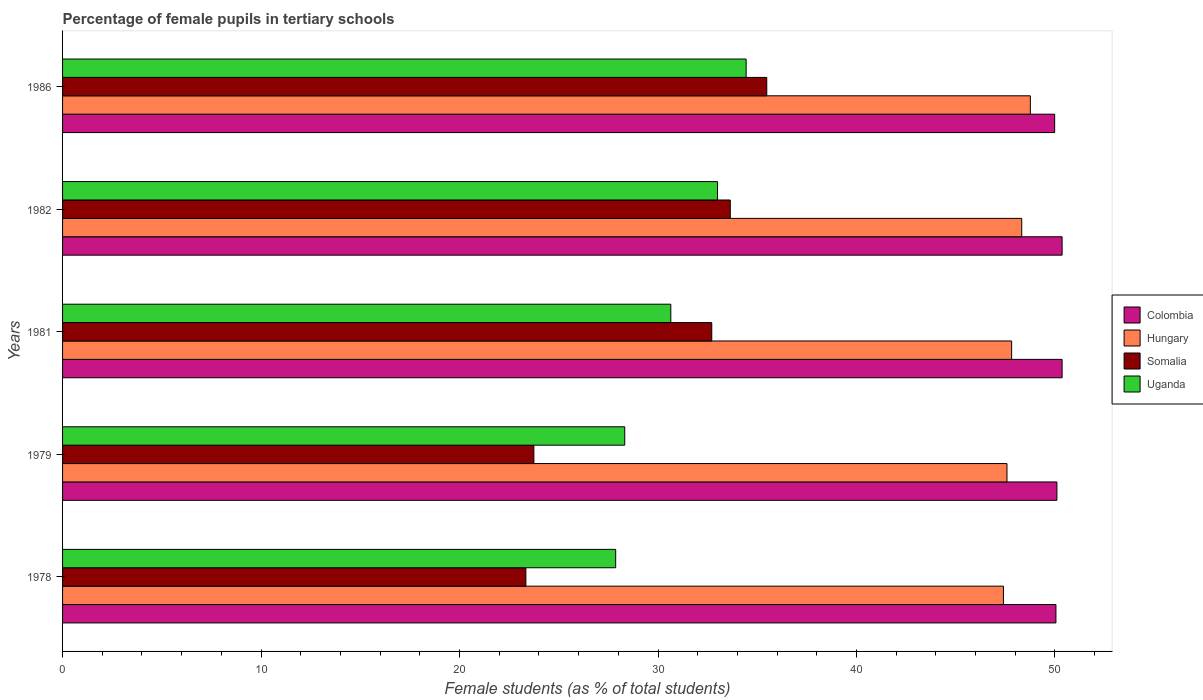How many groups of bars are there?
Provide a succinct answer. 5. Are the number of bars on each tick of the Y-axis equal?
Your answer should be compact. Yes. How many bars are there on the 4th tick from the top?
Your answer should be very brief. 4. In how many cases, is the number of bars for a given year not equal to the number of legend labels?
Give a very brief answer. 0. What is the percentage of female pupils in tertiary schools in Hungary in 1986?
Your answer should be compact. 48.76. Across all years, what is the maximum percentage of female pupils in tertiary schools in Colombia?
Offer a very short reply. 50.36. Across all years, what is the minimum percentage of female pupils in tertiary schools in Colombia?
Make the answer very short. 49.98. In which year was the percentage of female pupils in tertiary schools in Somalia minimum?
Ensure brevity in your answer.  1978. What is the total percentage of female pupils in tertiary schools in Somalia in the graph?
Offer a very short reply. 148.92. What is the difference between the percentage of female pupils in tertiary schools in Somalia in 1978 and that in 1982?
Provide a short and direct response. -10.3. What is the difference between the percentage of female pupils in tertiary schools in Uganda in 1981 and the percentage of female pupils in tertiary schools in Colombia in 1979?
Offer a terse response. -19.45. What is the average percentage of female pupils in tertiary schools in Hungary per year?
Keep it short and to the point. 47.98. In the year 1986, what is the difference between the percentage of female pupils in tertiary schools in Colombia and percentage of female pupils in tertiary schools in Somalia?
Make the answer very short. 14.51. In how many years, is the percentage of female pupils in tertiary schools in Uganda greater than 10 %?
Ensure brevity in your answer.  5. What is the ratio of the percentage of female pupils in tertiary schools in Uganda in 1982 to that in 1986?
Provide a succinct answer. 0.96. Is the percentage of female pupils in tertiary schools in Colombia in 1982 less than that in 1986?
Keep it short and to the point. No. Is the difference between the percentage of female pupils in tertiary schools in Colombia in 1978 and 1982 greater than the difference between the percentage of female pupils in tertiary schools in Somalia in 1978 and 1982?
Offer a very short reply. Yes. What is the difference between the highest and the second highest percentage of female pupils in tertiary schools in Somalia?
Your answer should be very brief. 1.84. What is the difference between the highest and the lowest percentage of female pupils in tertiary schools in Somalia?
Your answer should be compact. 12.14. In how many years, is the percentage of female pupils in tertiary schools in Hungary greater than the average percentage of female pupils in tertiary schools in Hungary taken over all years?
Give a very brief answer. 2. Is it the case that in every year, the sum of the percentage of female pupils in tertiary schools in Somalia and percentage of female pupils in tertiary schools in Uganda is greater than the sum of percentage of female pupils in tertiary schools in Hungary and percentage of female pupils in tertiary schools in Colombia?
Provide a short and direct response. No. What does the 1st bar from the top in 1979 represents?
Provide a succinct answer. Uganda. What does the 4th bar from the bottom in 1986 represents?
Your answer should be very brief. Uganda. Is it the case that in every year, the sum of the percentage of female pupils in tertiary schools in Uganda and percentage of female pupils in tertiary schools in Colombia is greater than the percentage of female pupils in tertiary schools in Hungary?
Ensure brevity in your answer.  Yes. How many bars are there?
Your answer should be very brief. 20. Are all the bars in the graph horizontal?
Provide a succinct answer. Yes. How many years are there in the graph?
Offer a very short reply. 5. What is the difference between two consecutive major ticks on the X-axis?
Offer a very short reply. 10. Are the values on the major ticks of X-axis written in scientific E-notation?
Give a very brief answer. No. Does the graph contain any zero values?
Your response must be concise. No. Does the graph contain grids?
Keep it short and to the point. No. What is the title of the graph?
Make the answer very short. Percentage of female pupils in tertiary schools. Does "Arab World" appear as one of the legend labels in the graph?
Your answer should be very brief. No. What is the label or title of the X-axis?
Ensure brevity in your answer.  Female students (as % of total students). What is the Female students (as % of total students) in Colombia in 1978?
Ensure brevity in your answer.  50.05. What is the Female students (as % of total students) of Hungary in 1978?
Provide a short and direct response. 47.4. What is the Female students (as % of total students) in Somalia in 1978?
Your response must be concise. 23.34. What is the Female students (as % of total students) in Uganda in 1978?
Ensure brevity in your answer.  27.87. What is the Female students (as % of total students) in Colombia in 1979?
Provide a short and direct response. 50.1. What is the Female students (as % of total students) of Hungary in 1979?
Your response must be concise. 47.58. What is the Female students (as % of total students) in Somalia in 1979?
Keep it short and to the point. 23.75. What is the Female students (as % of total students) of Uganda in 1979?
Your answer should be compact. 28.32. What is the Female students (as % of total students) of Colombia in 1981?
Keep it short and to the point. 50.36. What is the Female students (as % of total students) of Hungary in 1981?
Provide a succinct answer. 47.82. What is the Female students (as % of total students) in Somalia in 1981?
Make the answer very short. 32.71. What is the Female students (as % of total students) in Uganda in 1981?
Your response must be concise. 30.65. What is the Female students (as % of total students) in Colombia in 1982?
Offer a very short reply. 50.36. What is the Female students (as % of total students) of Hungary in 1982?
Your answer should be compact. 48.33. What is the Female students (as % of total students) of Somalia in 1982?
Your answer should be compact. 33.64. What is the Female students (as % of total students) of Uganda in 1982?
Provide a succinct answer. 33. What is the Female students (as % of total students) in Colombia in 1986?
Your answer should be compact. 49.98. What is the Female students (as % of total students) of Hungary in 1986?
Offer a terse response. 48.76. What is the Female students (as % of total students) of Somalia in 1986?
Offer a terse response. 35.48. What is the Female students (as % of total students) of Uganda in 1986?
Give a very brief answer. 34.44. Across all years, what is the maximum Female students (as % of total students) in Colombia?
Keep it short and to the point. 50.36. Across all years, what is the maximum Female students (as % of total students) of Hungary?
Offer a terse response. 48.76. Across all years, what is the maximum Female students (as % of total students) of Somalia?
Your answer should be very brief. 35.48. Across all years, what is the maximum Female students (as % of total students) in Uganda?
Ensure brevity in your answer.  34.44. Across all years, what is the minimum Female students (as % of total students) in Colombia?
Give a very brief answer. 49.98. Across all years, what is the minimum Female students (as % of total students) in Hungary?
Your response must be concise. 47.4. Across all years, what is the minimum Female students (as % of total students) of Somalia?
Provide a succinct answer. 23.34. Across all years, what is the minimum Female students (as % of total students) of Uganda?
Offer a very short reply. 27.87. What is the total Female students (as % of total students) in Colombia in the graph?
Keep it short and to the point. 250.85. What is the total Female students (as % of total students) of Hungary in the graph?
Ensure brevity in your answer.  239.89. What is the total Female students (as % of total students) in Somalia in the graph?
Keep it short and to the point. 148.92. What is the total Female students (as % of total students) in Uganda in the graph?
Offer a very short reply. 154.28. What is the difference between the Female students (as % of total students) in Colombia in 1978 and that in 1979?
Keep it short and to the point. -0.05. What is the difference between the Female students (as % of total students) in Hungary in 1978 and that in 1979?
Provide a short and direct response. -0.18. What is the difference between the Female students (as % of total students) of Somalia in 1978 and that in 1979?
Make the answer very short. -0.4. What is the difference between the Female students (as % of total students) in Uganda in 1978 and that in 1979?
Provide a succinct answer. -0.46. What is the difference between the Female students (as % of total students) of Colombia in 1978 and that in 1981?
Provide a short and direct response. -0.31. What is the difference between the Female students (as % of total students) of Hungary in 1978 and that in 1981?
Offer a terse response. -0.41. What is the difference between the Female students (as % of total students) in Somalia in 1978 and that in 1981?
Your answer should be compact. -9.37. What is the difference between the Female students (as % of total students) in Uganda in 1978 and that in 1981?
Ensure brevity in your answer.  -2.78. What is the difference between the Female students (as % of total students) in Colombia in 1978 and that in 1982?
Your answer should be very brief. -0.31. What is the difference between the Female students (as % of total students) in Hungary in 1978 and that in 1982?
Keep it short and to the point. -0.92. What is the difference between the Female students (as % of total students) of Somalia in 1978 and that in 1982?
Provide a succinct answer. -10.3. What is the difference between the Female students (as % of total students) of Uganda in 1978 and that in 1982?
Your answer should be very brief. -5.13. What is the difference between the Female students (as % of total students) in Colombia in 1978 and that in 1986?
Ensure brevity in your answer.  0.06. What is the difference between the Female students (as % of total students) in Hungary in 1978 and that in 1986?
Your answer should be compact. -1.36. What is the difference between the Female students (as % of total students) of Somalia in 1978 and that in 1986?
Your response must be concise. -12.14. What is the difference between the Female students (as % of total students) in Uganda in 1978 and that in 1986?
Offer a terse response. -6.57. What is the difference between the Female students (as % of total students) of Colombia in 1979 and that in 1981?
Ensure brevity in your answer.  -0.26. What is the difference between the Female students (as % of total students) in Hungary in 1979 and that in 1981?
Offer a terse response. -0.23. What is the difference between the Female students (as % of total students) of Somalia in 1979 and that in 1981?
Your response must be concise. -8.96. What is the difference between the Female students (as % of total students) in Uganda in 1979 and that in 1981?
Ensure brevity in your answer.  -2.32. What is the difference between the Female students (as % of total students) in Colombia in 1979 and that in 1982?
Keep it short and to the point. -0.26. What is the difference between the Female students (as % of total students) in Hungary in 1979 and that in 1982?
Your response must be concise. -0.74. What is the difference between the Female students (as % of total students) of Somalia in 1979 and that in 1982?
Your response must be concise. -9.9. What is the difference between the Female students (as % of total students) of Uganda in 1979 and that in 1982?
Provide a short and direct response. -4.67. What is the difference between the Female students (as % of total students) in Colombia in 1979 and that in 1986?
Offer a very short reply. 0.11. What is the difference between the Female students (as % of total students) of Hungary in 1979 and that in 1986?
Your answer should be compact. -1.18. What is the difference between the Female students (as % of total students) in Somalia in 1979 and that in 1986?
Your answer should be compact. -11.73. What is the difference between the Female students (as % of total students) in Uganda in 1979 and that in 1986?
Your response must be concise. -6.12. What is the difference between the Female students (as % of total students) in Colombia in 1981 and that in 1982?
Make the answer very short. 0. What is the difference between the Female students (as % of total students) of Hungary in 1981 and that in 1982?
Provide a short and direct response. -0.51. What is the difference between the Female students (as % of total students) of Somalia in 1981 and that in 1982?
Make the answer very short. -0.93. What is the difference between the Female students (as % of total students) in Uganda in 1981 and that in 1982?
Keep it short and to the point. -2.35. What is the difference between the Female students (as % of total students) of Colombia in 1981 and that in 1986?
Your answer should be very brief. 0.38. What is the difference between the Female students (as % of total students) in Hungary in 1981 and that in 1986?
Ensure brevity in your answer.  -0.94. What is the difference between the Female students (as % of total students) in Somalia in 1981 and that in 1986?
Keep it short and to the point. -2.77. What is the difference between the Female students (as % of total students) of Uganda in 1981 and that in 1986?
Your response must be concise. -3.8. What is the difference between the Female students (as % of total students) in Colombia in 1982 and that in 1986?
Provide a succinct answer. 0.38. What is the difference between the Female students (as % of total students) in Hungary in 1982 and that in 1986?
Offer a terse response. -0.43. What is the difference between the Female students (as % of total students) of Somalia in 1982 and that in 1986?
Make the answer very short. -1.84. What is the difference between the Female students (as % of total students) of Uganda in 1982 and that in 1986?
Provide a short and direct response. -1.44. What is the difference between the Female students (as % of total students) of Colombia in 1978 and the Female students (as % of total students) of Hungary in 1979?
Your answer should be compact. 2.47. What is the difference between the Female students (as % of total students) of Colombia in 1978 and the Female students (as % of total students) of Somalia in 1979?
Offer a very short reply. 26.3. What is the difference between the Female students (as % of total students) of Colombia in 1978 and the Female students (as % of total students) of Uganda in 1979?
Keep it short and to the point. 21.72. What is the difference between the Female students (as % of total students) of Hungary in 1978 and the Female students (as % of total students) of Somalia in 1979?
Make the answer very short. 23.66. What is the difference between the Female students (as % of total students) in Hungary in 1978 and the Female students (as % of total students) in Uganda in 1979?
Ensure brevity in your answer.  19.08. What is the difference between the Female students (as % of total students) in Somalia in 1978 and the Female students (as % of total students) in Uganda in 1979?
Keep it short and to the point. -4.98. What is the difference between the Female students (as % of total students) in Colombia in 1978 and the Female students (as % of total students) in Hungary in 1981?
Ensure brevity in your answer.  2.23. What is the difference between the Female students (as % of total students) in Colombia in 1978 and the Female students (as % of total students) in Somalia in 1981?
Your answer should be compact. 17.34. What is the difference between the Female students (as % of total students) in Colombia in 1978 and the Female students (as % of total students) in Uganda in 1981?
Your answer should be very brief. 19.4. What is the difference between the Female students (as % of total students) in Hungary in 1978 and the Female students (as % of total students) in Somalia in 1981?
Keep it short and to the point. 14.7. What is the difference between the Female students (as % of total students) in Hungary in 1978 and the Female students (as % of total students) in Uganda in 1981?
Your response must be concise. 16.76. What is the difference between the Female students (as % of total students) in Somalia in 1978 and the Female students (as % of total students) in Uganda in 1981?
Offer a terse response. -7.3. What is the difference between the Female students (as % of total students) in Colombia in 1978 and the Female students (as % of total students) in Hungary in 1982?
Offer a very short reply. 1.72. What is the difference between the Female students (as % of total students) of Colombia in 1978 and the Female students (as % of total students) of Somalia in 1982?
Make the answer very short. 16.41. What is the difference between the Female students (as % of total students) in Colombia in 1978 and the Female students (as % of total students) in Uganda in 1982?
Offer a very short reply. 17.05. What is the difference between the Female students (as % of total students) of Hungary in 1978 and the Female students (as % of total students) of Somalia in 1982?
Your answer should be compact. 13.76. What is the difference between the Female students (as % of total students) in Hungary in 1978 and the Female students (as % of total students) in Uganda in 1982?
Offer a very short reply. 14.4. What is the difference between the Female students (as % of total students) of Somalia in 1978 and the Female students (as % of total students) of Uganda in 1982?
Provide a short and direct response. -9.66. What is the difference between the Female students (as % of total students) of Colombia in 1978 and the Female students (as % of total students) of Hungary in 1986?
Provide a succinct answer. 1.29. What is the difference between the Female students (as % of total students) in Colombia in 1978 and the Female students (as % of total students) in Somalia in 1986?
Provide a succinct answer. 14.57. What is the difference between the Female students (as % of total students) of Colombia in 1978 and the Female students (as % of total students) of Uganda in 1986?
Provide a short and direct response. 15.61. What is the difference between the Female students (as % of total students) of Hungary in 1978 and the Female students (as % of total students) of Somalia in 1986?
Provide a short and direct response. 11.92. What is the difference between the Female students (as % of total students) of Hungary in 1978 and the Female students (as % of total students) of Uganda in 1986?
Your answer should be compact. 12.96. What is the difference between the Female students (as % of total students) of Somalia in 1978 and the Female students (as % of total students) of Uganda in 1986?
Keep it short and to the point. -11.1. What is the difference between the Female students (as % of total students) in Colombia in 1979 and the Female students (as % of total students) in Hungary in 1981?
Offer a very short reply. 2.28. What is the difference between the Female students (as % of total students) in Colombia in 1979 and the Female students (as % of total students) in Somalia in 1981?
Your response must be concise. 17.39. What is the difference between the Female students (as % of total students) of Colombia in 1979 and the Female students (as % of total students) of Uganda in 1981?
Your response must be concise. 19.45. What is the difference between the Female students (as % of total students) of Hungary in 1979 and the Female students (as % of total students) of Somalia in 1981?
Offer a very short reply. 14.87. What is the difference between the Female students (as % of total students) of Hungary in 1979 and the Female students (as % of total students) of Uganda in 1981?
Ensure brevity in your answer.  16.94. What is the difference between the Female students (as % of total students) in Somalia in 1979 and the Female students (as % of total students) in Uganda in 1981?
Offer a very short reply. -6.9. What is the difference between the Female students (as % of total students) of Colombia in 1979 and the Female students (as % of total students) of Hungary in 1982?
Your answer should be very brief. 1.77. What is the difference between the Female students (as % of total students) of Colombia in 1979 and the Female students (as % of total students) of Somalia in 1982?
Your answer should be very brief. 16.46. What is the difference between the Female students (as % of total students) of Colombia in 1979 and the Female students (as % of total students) of Uganda in 1982?
Your answer should be compact. 17.1. What is the difference between the Female students (as % of total students) of Hungary in 1979 and the Female students (as % of total students) of Somalia in 1982?
Ensure brevity in your answer.  13.94. What is the difference between the Female students (as % of total students) of Hungary in 1979 and the Female students (as % of total students) of Uganda in 1982?
Your answer should be very brief. 14.58. What is the difference between the Female students (as % of total students) of Somalia in 1979 and the Female students (as % of total students) of Uganda in 1982?
Your response must be concise. -9.25. What is the difference between the Female students (as % of total students) in Colombia in 1979 and the Female students (as % of total students) in Hungary in 1986?
Your answer should be compact. 1.34. What is the difference between the Female students (as % of total students) in Colombia in 1979 and the Female students (as % of total students) in Somalia in 1986?
Your answer should be very brief. 14.62. What is the difference between the Female students (as % of total students) in Colombia in 1979 and the Female students (as % of total students) in Uganda in 1986?
Your answer should be very brief. 15.66. What is the difference between the Female students (as % of total students) of Hungary in 1979 and the Female students (as % of total students) of Somalia in 1986?
Offer a very short reply. 12.1. What is the difference between the Female students (as % of total students) in Hungary in 1979 and the Female students (as % of total students) in Uganda in 1986?
Provide a short and direct response. 13.14. What is the difference between the Female students (as % of total students) of Somalia in 1979 and the Female students (as % of total students) of Uganda in 1986?
Offer a terse response. -10.7. What is the difference between the Female students (as % of total students) of Colombia in 1981 and the Female students (as % of total students) of Hungary in 1982?
Offer a terse response. 2.03. What is the difference between the Female students (as % of total students) of Colombia in 1981 and the Female students (as % of total students) of Somalia in 1982?
Provide a succinct answer. 16.72. What is the difference between the Female students (as % of total students) in Colombia in 1981 and the Female students (as % of total students) in Uganda in 1982?
Your response must be concise. 17.36. What is the difference between the Female students (as % of total students) in Hungary in 1981 and the Female students (as % of total students) in Somalia in 1982?
Give a very brief answer. 14.18. What is the difference between the Female students (as % of total students) of Hungary in 1981 and the Female students (as % of total students) of Uganda in 1982?
Make the answer very short. 14.82. What is the difference between the Female students (as % of total students) in Somalia in 1981 and the Female students (as % of total students) in Uganda in 1982?
Keep it short and to the point. -0.29. What is the difference between the Female students (as % of total students) of Colombia in 1981 and the Female students (as % of total students) of Hungary in 1986?
Your answer should be compact. 1.6. What is the difference between the Female students (as % of total students) of Colombia in 1981 and the Female students (as % of total students) of Somalia in 1986?
Ensure brevity in your answer.  14.88. What is the difference between the Female students (as % of total students) of Colombia in 1981 and the Female students (as % of total students) of Uganda in 1986?
Give a very brief answer. 15.92. What is the difference between the Female students (as % of total students) of Hungary in 1981 and the Female students (as % of total students) of Somalia in 1986?
Your response must be concise. 12.34. What is the difference between the Female students (as % of total students) in Hungary in 1981 and the Female students (as % of total students) in Uganda in 1986?
Provide a succinct answer. 13.38. What is the difference between the Female students (as % of total students) in Somalia in 1981 and the Female students (as % of total students) in Uganda in 1986?
Your answer should be very brief. -1.73. What is the difference between the Female students (as % of total students) in Colombia in 1982 and the Female students (as % of total students) in Hungary in 1986?
Offer a very short reply. 1.6. What is the difference between the Female students (as % of total students) of Colombia in 1982 and the Female students (as % of total students) of Somalia in 1986?
Your response must be concise. 14.88. What is the difference between the Female students (as % of total students) in Colombia in 1982 and the Female students (as % of total students) in Uganda in 1986?
Your answer should be very brief. 15.92. What is the difference between the Female students (as % of total students) in Hungary in 1982 and the Female students (as % of total students) in Somalia in 1986?
Your answer should be very brief. 12.85. What is the difference between the Female students (as % of total students) of Hungary in 1982 and the Female students (as % of total students) of Uganda in 1986?
Your response must be concise. 13.88. What is the difference between the Female students (as % of total students) in Somalia in 1982 and the Female students (as % of total students) in Uganda in 1986?
Provide a succinct answer. -0.8. What is the average Female students (as % of total students) in Colombia per year?
Ensure brevity in your answer.  50.17. What is the average Female students (as % of total students) of Hungary per year?
Your response must be concise. 47.98. What is the average Female students (as % of total students) in Somalia per year?
Offer a terse response. 29.78. What is the average Female students (as % of total students) in Uganda per year?
Keep it short and to the point. 30.86. In the year 1978, what is the difference between the Female students (as % of total students) of Colombia and Female students (as % of total students) of Hungary?
Your response must be concise. 2.65. In the year 1978, what is the difference between the Female students (as % of total students) in Colombia and Female students (as % of total students) in Somalia?
Provide a succinct answer. 26.71. In the year 1978, what is the difference between the Female students (as % of total students) in Colombia and Female students (as % of total students) in Uganda?
Your answer should be compact. 22.18. In the year 1978, what is the difference between the Female students (as % of total students) of Hungary and Female students (as % of total students) of Somalia?
Provide a short and direct response. 24.06. In the year 1978, what is the difference between the Female students (as % of total students) in Hungary and Female students (as % of total students) in Uganda?
Give a very brief answer. 19.54. In the year 1978, what is the difference between the Female students (as % of total students) in Somalia and Female students (as % of total students) in Uganda?
Your answer should be compact. -4.52. In the year 1979, what is the difference between the Female students (as % of total students) of Colombia and Female students (as % of total students) of Hungary?
Offer a terse response. 2.52. In the year 1979, what is the difference between the Female students (as % of total students) in Colombia and Female students (as % of total students) in Somalia?
Your answer should be compact. 26.35. In the year 1979, what is the difference between the Female students (as % of total students) in Colombia and Female students (as % of total students) in Uganda?
Your answer should be compact. 21.77. In the year 1979, what is the difference between the Female students (as % of total students) of Hungary and Female students (as % of total students) of Somalia?
Your response must be concise. 23.84. In the year 1979, what is the difference between the Female students (as % of total students) in Hungary and Female students (as % of total students) in Uganda?
Your answer should be compact. 19.26. In the year 1979, what is the difference between the Female students (as % of total students) of Somalia and Female students (as % of total students) of Uganda?
Keep it short and to the point. -4.58. In the year 1981, what is the difference between the Female students (as % of total students) in Colombia and Female students (as % of total students) in Hungary?
Your answer should be compact. 2.54. In the year 1981, what is the difference between the Female students (as % of total students) of Colombia and Female students (as % of total students) of Somalia?
Give a very brief answer. 17.65. In the year 1981, what is the difference between the Female students (as % of total students) of Colombia and Female students (as % of total students) of Uganda?
Provide a succinct answer. 19.71. In the year 1981, what is the difference between the Female students (as % of total students) in Hungary and Female students (as % of total students) in Somalia?
Provide a succinct answer. 15.11. In the year 1981, what is the difference between the Female students (as % of total students) of Hungary and Female students (as % of total students) of Uganda?
Ensure brevity in your answer.  17.17. In the year 1981, what is the difference between the Female students (as % of total students) in Somalia and Female students (as % of total students) in Uganda?
Make the answer very short. 2.06. In the year 1982, what is the difference between the Female students (as % of total students) in Colombia and Female students (as % of total students) in Hungary?
Ensure brevity in your answer.  2.03. In the year 1982, what is the difference between the Female students (as % of total students) of Colombia and Female students (as % of total students) of Somalia?
Provide a succinct answer. 16.72. In the year 1982, what is the difference between the Female students (as % of total students) in Colombia and Female students (as % of total students) in Uganda?
Your answer should be very brief. 17.36. In the year 1982, what is the difference between the Female students (as % of total students) of Hungary and Female students (as % of total students) of Somalia?
Your answer should be very brief. 14.68. In the year 1982, what is the difference between the Female students (as % of total students) of Hungary and Female students (as % of total students) of Uganda?
Provide a short and direct response. 15.33. In the year 1982, what is the difference between the Female students (as % of total students) of Somalia and Female students (as % of total students) of Uganda?
Keep it short and to the point. 0.64. In the year 1986, what is the difference between the Female students (as % of total students) of Colombia and Female students (as % of total students) of Hungary?
Keep it short and to the point. 1.23. In the year 1986, what is the difference between the Female students (as % of total students) of Colombia and Female students (as % of total students) of Somalia?
Make the answer very short. 14.51. In the year 1986, what is the difference between the Female students (as % of total students) in Colombia and Female students (as % of total students) in Uganda?
Offer a very short reply. 15.54. In the year 1986, what is the difference between the Female students (as % of total students) in Hungary and Female students (as % of total students) in Somalia?
Offer a very short reply. 13.28. In the year 1986, what is the difference between the Female students (as % of total students) in Hungary and Female students (as % of total students) in Uganda?
Offer a terse response. 14.32. In the year 1986, what is the difference between the Female students (as % of total students) of Somalia and Female students (as % of total students) of Uganda?
Provide a succinct answer. 1.04. What is the ratio of the Female students (as % of total students) in Colombia in 1978 to that in 1979?
Your answer should be compact. 1. What is the ratio of the Female students (as % of total students) in Hungary in 1978 to that in 1979?
Make the answer very short. 1. What is the ratio of the Female students (as % of total students) of Uganda in 1978 to that in 1979?
Your answer should be compact. 0.98. What is the ratio of the Female students (as % of total students) of Hungary in 1978 to that in 1981?
Keep it short and to the point. 0.99. What is the ratio of the Female students (as % of total students) in Somalia in 1978 to that in 1981?
Your answer should be very brief. 0.71. What is the ratio of the Female students (as % of total students) of Uganda in 1978 to that in 1981?
Your answer should be compact. 0.91. What is the ratio of the Female students (as % of total students) of Hungary in 1978 to that in 1982?
Provide a short and direct response. 0.98. What is the ratio of the Female students (as % of total students) in Somalia in 1978 to that in 1982?
Ensure brevity in your answer.  0.69. What is the ratio of the Female students (as % of total students) in Uganda in 1978 to that in 1982?
Your answer should be compact. 0.84. What is the ratio of the Female students (as % of total students) of Hungary in 1978 to that in 1986?
Your response must be concise. 0.97. What is the ratio of the Female students (as % of total students) of Somalia in 1978 to that in 1986?
Your answer should be compact. 0.66. What is the ratio of the Female students (as % of total students) of Uganda in 1978 to that in 1986?
Your response must be concise. 0.81. What is the ratio of the Female students (as % of total students) in Somalia in 1979 to that in 1981?
Keep it short and to the point. 0.73. What is the ratio of the Female students (as % of total students) of Uganda in 1979 to that in 1981?
Provide a short and direct response. 0.92. What is the ratio of the Female students (as % of total students) in Hungary in 1979 to that in 1982?
Offer a very short reply. 0.98. What is the ratio of the Female students (as % of total students) in Somalia in 1979 to that in 1982?
Your answer should be very brief. 0.71. What is the ratio of the Female students (as % of total students) of Uganda in 1979 to that in 1982?
Provide a short and direct response. 0.86. What is the ratio of the Female students (as % of total students) in Colombia in 1979 to that in 1986?
Provide a succinct answer. 1. What is the ratio of the Female students (as % of total students) in Hungary in 1979 to that in 1986?
Provide a short and direct response. 0.98. What is the ratio of the Female students (as % of total students) in Somalia in 1979 to that in 1986?
Provide a short and direct response. 0.67. What is the ratio of the Female students (as % of total students) of Uganda in 1979 to that in 1986?
Your answer should be very brief. 0.82. What is the ratio of the Female students (as % of total students) in Hungary in 1981 to that in 1982?
Your answer should be very brief. 0.99. What is the ratio of the Female students (as % of total students) of Somalia in 1981 to that in 1982?
Make the answer very short. 0.97. What is the ratio of the Female students (as % of total students) in Uganda in 1981 to that in 1982?
Provide a short and direct response. 0.93. What is the ratio of the Female students (as % of total students) in Colombia in 1981 to that in 1986?
Offer a very short reply. 1.01. What is the ratio of the Female students (as % of total students) of Hungary in 1981 to that in 1986?
Provide a short and direct response. 0.98. What is the ratio of the Female students (as % of total students) of Somalia in 1981 to that in 1986?
Give a very brief answer. 0.92. What is the ratio of the Female students (as % of total students) in Uganda in 1981 to that in 1986?
Offer a very short reply. 0.89. What is the ratio of the Female students (as % of total students) of Colombia in 1982 to that in 1986?
Give a very brief answer. 1.01. What is the ratio of the Female students (as % of total students) in Hungary in 1982 to that in 1986?
Your response must be concise. 0.99. What is the ratio of the Female students (as % of total students) of Somalia in 1982 to that in 1986?
Provide a succinct answer. 0.95. What is the ratio of the Female students (as % of total students) of Uganda in 1982 to that in 1986?
Provide a succinct answer. 0.96. What is the difference between the highest and the second highest Female students (as % of total students) in Colombia?
Your answer should be very brief. 0. What is the difference between the highest and the second highest Female students (as % of total students) of Hungary?
Your response must be concise. 0.43. What is the difference between the highest and the second highest Female students (as % of total students) in Somalia?
Offer a very short reply. 1.84. What is the difference between the highest and the second highest Female students (as % of total students) in Uganda?
Your response must be concise. 1.44. What is the difference between the highest and the lowest Female students (as % of total students) of Colombia?
Provide a short and direct response. 0.38. What is the difference between the highest and the lowest Female students (as % of total students) of Hungary?
Offer a terse response. 1.36. What is the difference between the highest and the lowest Female students (as % of total students) of Somalia?
Ensure brevity in your answer.  12.14. What is the difference between the highest and the lowest Female students (as % of total students) of Uganda?
Give a very brief answer. 6.57. 